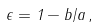<formula> <loc_0><loc_0><loc_500><loc_500>\epsilon = 1 - b / a \, ,</formula> 